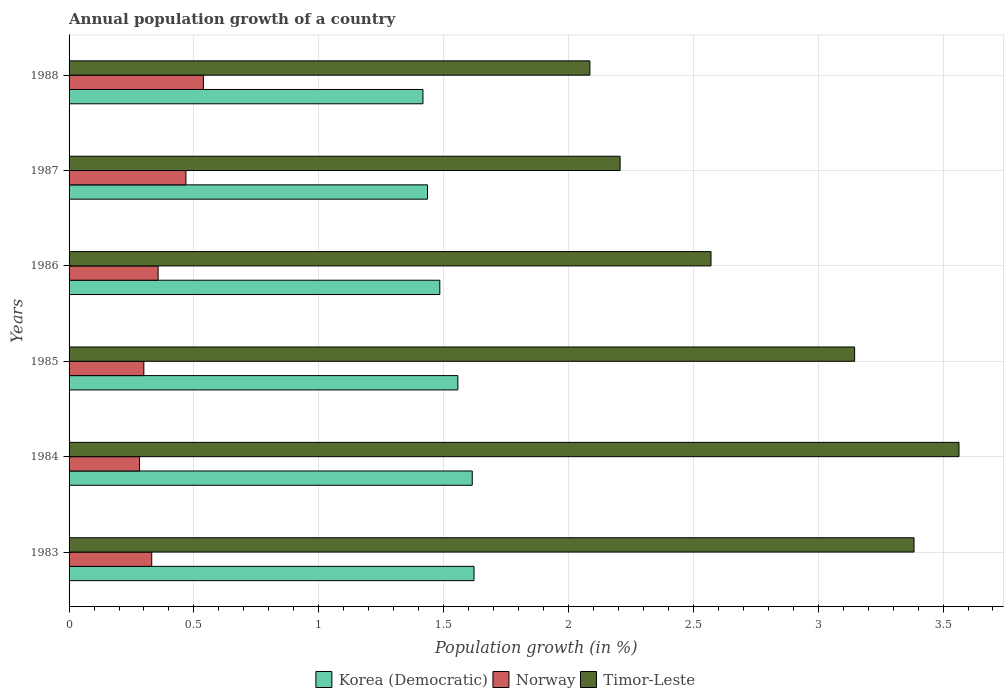How many different coloured bars are there?
Keep it short and to the point. 3. How many groups of bars are there?
Provide a succinct answer. 6. Are the number of bars per tick equal to the number of legend labels?
Provide a succinct answer. Yes. How many bars are there on the 2nd tick from the top?
Give a very brief answer. 3. What is the label of the 2nd group of bars from the top?
Your response must be concise. 1987. What is the annual population growth in Korea (Democratic) in 1987?
Offer a very short reply. 1.44. Across all years, what is the maximum annual population growth in Korea (Democratic)?
Your answer should be compact. 1.62. Across all years, what is the minimum annual population growth in Korea (Democratic)?
Your answer should be compact. 1.42. In which year was the annual population growth in Timor-Leste maximum?
Give a very brief answer. 1984. What is the total annual population growth in Norway in the graph?
Give a very brief answer. 2.28. What is the difference between the annual population growth in Korea (Democratic) in 1983 and that in 1986?
Ensure brevity in your answer.  0.14. What is the difference between the annual population growth in Norway in 1988 and the annual population growth in Timor-Leste in 1983?
Keep it short and to the point. -2.85. What is the average annual population growth in Korea (Democratic) per year?
Offer a terse response. 1.52. In the year 1987, what is the difference between the annual population growth in Timor-Leste and annual population growth in Korea (Democratic)?
Offer a terse response. 0.77. In how many years, is the annual population growth in Korea (Democratic) greater than 2.7 %?
Offer a very short reply. 0. What is the ratio of the annual population growth in Korea (Democratic) in 1986 to that in 1987?
Provide a succinct answer. 1.03. Is the annual population growth in Timor-Leste in 1984 less than that in 1988?
Your response must be concise. No. Is the difference between the annual population growth in Timor-Leste in 1985 and 1986 greater than the difference between the annual population growth in Korea (Democratic) in 1985 and 1986?
Offer a very short reply. Yes. What is the difference between the highest and the second highest annual population growth in Korea (Democratic)?
Your response must be concise. 0.01. What is the difference between the highest and the lowest annual population growth in Korea (Democratic)?
Provide a succinct answer. 0.2. In how many years, is the annual population growth in Timor-Leste greater than the average annual population growth in Timor-Leste taken over all years?
Give a very brief answer. 3. What does the 2nd bar from the bottom in 1987 represents?
Offer a terse response. Norway. Are all the bars in the graph horizontal?
Ensure brevity in your answer.  Yes. What is the difference between two consecutive major ticks on the X-axis?
Provide a short and direct response. 0.5. Does the graph contain any zero values?
Offer a very short reply. No. Does the graph contain grids?
Give a very brief answer. Yes. How many legend labels are there?
Keep it short and to the point. 3. What is the title of the graph?
Offer a terse response. Annual population growth of a country. What is the label or title of the X-axis?
Offer a terse response. Population growth (in %). What is the label or title of the Y-axis?
Your answer should be compact. Years. What is the Population growth (in %) in Korea (Democratic) in 1983?
Your response must be concise. 1.62. What is the Population growth (in %) in Norway in 1983?
Offer a terse response. 0.33. What is the Population growth (in %) of Timor-Leste in 1983?
Your answer should be very brief. 3.38. What is the Population growth (in %) of Korea (Democratic) in 1984?
Make the answer very short. 1.61. What is the Population growth (in %) in Norway in 1984?
Ensure brevity in your answer.  0.28. What is the Population growth (in %) in Timor-Leste in 1984?
Keep it short and to the point. 3.56. What is the Population growth (in %) in Korea (Democratic) in 1985?
Your answer should be compact. 1.56. What is the Population growth (in %) in Norway in 1985?
Your answer should be very brief. 0.3. What is the Population growth (in %) of Timor-Leste in 1985?
Provide a succinct answer. 3.15. What is the Population growth (in %) in Korea (Democratic) in 1986?
Your answer should be very brief. 1.48. What is the Population growth (in %) of Norway in 1986?
Provide a succinct answer. 0.36. What is the Population growth (in %) of Timor-Leste in 1986?
Provide a short and direct response. 2.57. What is the Population growth (in %) in Korea (Democratic) in 1987?
Give a very brief answer. 1.44. What is the Population growth (in %) of Norway in 1987?
Your answer should be compact. 0.47. What is the Population growth (in %) in Timor-Leste in 1987?
Give a very brief answer. 2.21. What is the Population growth (in %) in Korea (Democratic) in 1988?
Offer a very short reply. 1.42. What is the Population growth (in %) of Norway in 1988?
Give a very brief answer. 0.54. What is the Population growth (in %) of Timor-Leste in 1988?
Offer a terse response. 2.09. Across all years, what is the maximum Population growth (in %) of Korea (Democratic)?
Provide a succinct answer. 1.62. Across all years, what is the maximum Population growth (in %) in Norway?
Your answer should be compact. 0.54. Across all years, what is the maximum Population growth (in %) in Timor-Leste?
Make the answer very short. 3.56. Across all years, what is the minimum Population growth (in %) of Korea (Democratic)?
Your answer should be compact. 1.42. Across all years, what is the minimum Population growth (in %) in Norway?
Ensure brevity in your answer.  0.28. Across all years, what is the minimum Population growth (in %) in Timor-Leste?
Keep it short and to the point. 2.09. What is the total Population growth (in %) of Korea (Democratic) in the graph?
Make the answer very short. 9.13. What is the total Population growth (in %) of Norway in the graph?
Your answer should be very brief. 2.28. What is the total Population growth (in %) in Timor-Leste in the graph?
Keep it short and to the point. 16.96. What is the difference between the Population growth (in %) in Korea (Democratic) in 1983 and that in 1984?
Your response must be concise. 0.01. What is the difference between the Population growth (in %) of Norway in 1983 and that in 1984?
Offer a very short reply. 0.05. What is the difference between the Population growth (in %) in Timor-Leste in 1983 and that in 1984?
Ensure brevity in your answer.  -0.18. What is the difference between the Population growth (in %) of Korea (Democratic) in 1983 and that in 1985?
Your response must be concise. 0.06. What is the difference between the Population growth (in %) in Norway in 1983 and that in 1985?
Ensure brevity in your answer.  0.03. What is the difference between the Population growth (in %) in Timor-Leste in 1983 and that in 1985?
Give a very brief answer. 0.24. What is the difference between the Population growth (in %) of Korea (Democratic) in 1983 and that in 1986?
Provide a succinct answer. 0.14. What is the difference between the Population growth (in %) in Norway in 1983 and that in 1986?
Make the answer very short. -0.03. What is the difference between the Population growth (in %) of Timor-Leste in 1983 and that in 1986?
Your answer should be compact. 0.81. What is the difference between the Population growth (in %) in Korea (Democratic) in 1983 and that in 1987?
Give a very brief answer. 0.19. What is the difference between the Population growth (in %) of Norway in 1983 and that in 1987?
Make the answer very short. -0.14. What is the difference between the Population growth (in %) of Timor-Leste in 1983 and that in 1987?
Offer a very short reply. 1.18. What is the difference between the Population growth (in %) in Korea (Democratic) in 1983 and that in 1988?
Provide a succinct answer. 0.2. What is the difference between the Population growth (in %) in Norway in 1983 and that in 1988?
Give a very brief answer. -0.21. What is the difference between the Population growth (in %) of Timor-Leste in 1983 and that in 1988?
Offer a very short reply. 1.3. What is the difference between the Population growth (in %) of Korea (Democratic) in 1984 and that in 1985?
Provide a short and direct response. 0.06. What is the difference between the Population growth (in %) in Norway in 1984 and that in 1985?
Provide a short and direct response. -0.02. What is the difference between the Population growth (in %) in Timor-Leste in 1984 and that in 1985?
Offer a terse response. 0.42. What is the difference between the Population growth (in %) of Korea (Democratic) in 1984 and that in 1986?
Provide a succinct answer. 0.13. What is the difference between the Population growth (in %) of Norway in 1984 and that in 1986?
Make the answer very short. -0.07. What is the difference between the Population growth (in %) of Korea (Democratic) in 1984 and that in 1987?
Offer a terse response. 0.18. What is the difference between the Population growth (in %) of Norway in 1984 and that in 1987?
Your answer should be compact. -0.19. What is the difference between the Population growth (in %) of Timor-Leste in 1984 and that in 1987?
Give a very brief answer. 1.36. What is the difference between the Population growth (in %) in Korea (Democratic) in 1984 and that in 1988?
Offer a very short reply. 0.2. What is the difference between the Population growth (in %) of Norway in 1984 and that in 1988?
Your answer should be compact. -0.26. What is the difference between the Population growth (in %) of Timor-Leste in 1984 and that in 1988?
Give a very brief answer. 1.48. What is the difference between the Population growth (in %) in Korea (Democratic) in 1985 and that in 1986?
Ensure brevity in your answer.  0.07. What is the difference between the Population growth (in %) in Norway in 1985 and that in 1986?
Your answer should be compact. -0.06. What is the difference between the Population growth (in %) in Timor-Leste in 1985 and that in 1986?
Your answer should be very brief. 0.58. What is the difference between the Population growth (in %) in Korea (Democratic) in 1985 and that in 1987?
Offer a terse response. 0.12. What is the difference between the Population growth (in %) of Norway in 1985 and that in 1987?
Ensure brevity in your answer.  -0.17. What is the difference between the Population growth (in %) in Timor-Leste in 1985 and that in 1987?
Your response must be concise. 0.94. What is the difference between the Population growth (in %) of Korea (Democratic) in 1985 and that in 1988?
Your response must be concise. 0.14. What is the difference between the Population growth (in %) of Norway in 1985 and that in 1988?
Offer a terse response. -0.24. What is the difference between the Population growth (in %) of Timor-Leste in 1985 and that in 1988?
Provide a short and direct response. 1.06. What is the difference between the Population growth (in %) in Korea (Democratic) in 1986 and that in 1987?
Your answer should be very brief. 0.05. What is the difference between the Population growth (in %) of Norway in 1986 and that in 1987?
Provide a succinct answer. -0.11. What is the difference between the Population growth (in %) in Timor-Leste in 1986 and that in 1987?
Your answer should be compact. 0.36. What is the difference between the Population growth (in %) of Korea (Democratic) in 1986 and that in 1988?
Offer a terse response. 0.07. What is the difference between the Population growth (in %) of Norway in 1986 and that in 1988?
Provide a succinct answer. -0.18. What is the difference between the Population growth (in %) in Timor-Leste in 1986 and that in 1988?
Give a very brief answer. 0.48. What is the difference between the Population growth (in %) in Korea (Democratic) in 1987 and that in 1988?
Provide a short and direct response. 0.02. What is the difference between the Population growth (in %) in Norway in 1987 and that in 1988?
Provide a short and direct response. -0.07. What is the difference between the Population growth (in %) in Timor-Leste in 1987 and that in 1988?
Provide a succinct answer. 0.12. What is the difference between the Population growth (in %) in Korea (Democratic) in 1983 and the Population growth (in %) in Norway in 1984?
Your answer should be compact. 1.34. What is the difference between the Population growth (in %) in Korea (Democratic) in 1983 and the Population growth (in %) in Timor-Leste in 1984?
Provide a succinct answer. -1.94. What is the difference between the Population growth (in %) of Norway in 1983 and the Population growth (in %) of Timor-Leste in 1984?
Ensure brevity in your answer.  -3.23. What is the difference between the Population growth (in %) in Korea (Democratic) in 1983 and the Population growth (in %) in Norway in 1985?
Your answer should be very brief. 1.32. What is the difference between the Population growth (in %) in Korea (Democratic) in 1983 and the Population growth (in %) in Timor-Leste in 1985?
Keep it short and to the point. -1.52. What is the difference between the Population growth (in %) in Norway in 1983 and the Population growth (in %) in Timor-Leste in 1985?
Offer a very short reply. -2.81. What is the difference between the Population growth (in %) of Korea (Democratic) in 1983 and the Population growth (in %) of Norway in 1986?
Make the answer very short. 1.26. What is the difference between the Population growth (in %) of Korea (Democratic) in 1983 and the Population growth (in %) of Timor-Leste in 1986?
Offer a very short reply. -0.95. What is the difference between the Population growth (in %) of Norway in 1983 and the Population growth (in %) of Timor-Leste in 1986?
Offer a terse response. -2.24. What is the difference between the Population growth (in %) of Korea (Democratic) in 1983 and the Population growth (in %) of Norway in 1987?
Ensure brevity in your answer.  1.15. What is the difference between the Population growth (in %) in Korea (Democratic) in 1983 and the Population growth (in %) in Timor-Leste in 1987?
Offer a very short reply. -0.59. What is the difference between the Population growth (in %) of Norway in 1983 and the Population growth (in %) of Timor-Leste in 1987?
Make the answer very short. -1.88. What is the difference between the Population growth (in %) of Korea (Democratic) in 1983 and the Population growth (in %) of Norway in 1988?
Provide a succinct answer. 1.08. What is the difference between the Population growth (in %) in Korea (Democratic) in 1983 and the Population growth (in %) in Timor-Leste in 1988?
Keep it short and to the point. -0.46. What is the difference between the Population growth (in %) in Norway in 1983 and the Population growth (in %) in Timor-Leste in 1988?
Offer a very short reply. -1.75. What is the difference between the Population growth (in %) of Korea (Democratic) in 1984 and the Population growth (in %) of Norway in 1985?
Offer a terse response. 1.32. What is the difference between the Population growth (in %) of Korea (Democratic) in 1984 and the Population growth (in %) of Timor-Leste in 1985?
Your answer should be compact. -1.53. What is the difference between the Population growth (in %) in Norway in 1984 and the Population growth (in %) in Timor-Leste in 1985?
Your answer should be compact. -2.86. What is the difference between the Population growth (in %) of Korea (Democratic) in 1984 and the Population growth (in %) of Norway in 1986?
Your answer should be very brief. 1.26. What is the difference between the Population growth (in %) in Korea (Democratic) in 1984 and the Population growth (in %) in Timor-Leste in 1986?
Give a very brief answer. -0.96. What is the difference between the Population growth (in %) in Norway in 1984 and the Population growth (in %) in Timor-Leste in 1986?
Your response must be concise. -2.29. What is the difference between the Population growth (in %) in Korea (Democratic) in 1984 and the Population growth (in %) in Norway in 1987?
Ensure brevity in your answer.  1.15. What is the difference between the Population growth (in %) in Korea (Democratic) in 1984 and the Population growth (in %) in Timor-Leste in 1987?
Ensure brevity in your answer.  -0.59. What is the difference between the Population growth (in %) in Norway in 1984 and the Population growth (in %) in Timor-Leste in 1987?
Provide a succinct answer. -1.92. What is the difference between the Population growth (in %) of Korea (Democratic) in 1984 and the Population growth (in %) of Norway in 1988?
Make the answer very short. 1.08. What is the difference between the Population growth (in %) of Korea (Democratic) in 1984 and the Population growth (in %) of Timor-Leste in 1988?
Your response must be concise. -0.47. What is the difference between the Population growth (in %) of Norway in 1984 and the Population growth (in %) of Timor-Leste in 1988?
Your answer should be very brief. -1.8. What is the difference between the Population growth (in %) in Korea (Democratic) in 1985 and the Population growth (in %) in Norway in 1986?
Your answer should be compact. 1.2. What is the difference between the Population growth (in %) in Korea (Democratic) in 1985 and the Population growth (in %) in Timor-Leste in 1986?
Your answer should be compact. -1.01. What is the difference between the Population growth (in %) of Norway in 1985 and the Population growth (in %) of Timor-Leste in 1986?
Offer a very short reply. -2.27. What is the difference between the Population growth (in %) in Korea (Democratic) in 1985 and the Population growth (in %) in Norway in 1987?
Provide a short and direct response. 1.09. What is the difference between the Population growth (in %) of Korea (Democratic) in 1985 and the Population growth (in %) of Timor-Leste in 1987?
Give a very brief answer. -0.65. What is the difference between the Population growth (in %) in Norway in 1985 and the Population growth (in %) in Timor-Leste in 1987?
Ensure brevity in your answer.  -1.91. What is the difference between the Population growth (in %) in Korea (Democratic) in 1985 and the Population growth (in %) in Timor-Leste in 1988?
Make the answer very short. -0.53. What is the difference between the Population growth (in %) of Norway in 1985 and the Population growth (in %) of Timor-Leste in 1988?
Your answer should be very brief. -1.79. What is the difference between the Population growth (in %) of Korea (Democratic) in 1986 and the Population growth (in %) of Norway in 1987?
Provide a succinct answer. 1.02. What is the difference between the Population growth (in %) of Korea (Democratic) in 1986 and the Population growth (in %) of Timor-Leste in 1987?
Offer a very short reply. -0.72. What is the difference between the Population growth (in %) in Norway in 1986 and the Population growth (in %) in Timor-Leste in 1987?
Make the answer very short. -1.85. What is the difference between the Population growth (in %) in Korea (Democratic) in 1986 and the Population growth (in %) in Norway in 1988?
Keep it short and to the point. 0.95. What is the difference between the Population growth (in %) in Korea (Democratic) in 1986 and the Population growth (in %) in Timor-Leste in 1988?
Ensure brevity in your answer.  -0.6. What is the difference between the Population growth (in %) of Norway in 1986 and the Population growth (in %) of Timor-Leste in 1988?
Your response must be concise. -1.73. What is the difference between the Population growth (in %) of Korea (Democratic) in 1987 and the Population growth (in %) of Norway in 1988?
Offer a terse response. 0.9. What is the difference between the Population growth (in %) of Korea (Democratic) in 1987 and the Population growth (in %) of Timor-Leste in 1988?
Ensure brevity in your answer.  -0.65. What is the difference between the Population growth (in %) in Norway in 1987 and the Population growth (in %) in Timor-Leste in 1988?
Provide a succinct answer. -1.62. What is the average Population growth (in %) of Korea (Democratic) per year?
Keep it short and to the point. 1.52. What is the average Population growth (in %) in Norway per year?
Provide a succinct answer. 0.38. What is the average Population growth (in %) in Timor-Leste per year?
Give a very brief answer. 2.83. In the year 1983, what is the difference between the Population growth (in %) of Korea (Democratic) and Population growth (in %) of Norway?
Your answer should be very brief. 1.29. In the year 1983, what is the difference between the Population growth (in %) in Korea (Democratic) and Population growth (in %) in Timor-Leste?
Make the answer very short. -1.76. In the year 1983, what is the difference between the Population growth (in %) of Norway and Population growth (in %) of Timor-Leste?
Make the answer very short. -3.05. In the year 1984, what is the difference between the Population growth (in %) in Korea (Democratic) and Population growth (in %) in Norway?
Offer a terse response. 1.33. In the year 1984, what is the difference between the Population growth (in %) of Korea (Democratic) and Population growth (in %) of Timor-Leste?
Provide a succinct answer. -1.95. In the year 1984, what is the difference between the Population growth (in %) of Norway and Population growth (in %) of Timor-Leste?
Offer a terse response. -3.28. In the year 1985, what is the difference between the Population growth (in %) of Korea (Democratic) and Population growth (in %) of Norway?
Your answer should be very brief. 1.26. In the year 1985, what is the difference between the Population growth (in %) of Korea (Democratic) and Population growth (in %) of Timor-Leste?
Provide a succinct answer. -1.59. In the year 1985, what is the difference between the Population growth (in %) in Norway and Population growth (in %) in Timor-Leste?
Offer a very short reply. -2.85. In the year 1986, what is the difference between the Population growth (in %) in Korea (Democratic) and Population growth (in %) in Norway?
Provide a short and direct response. 1.13. In the year 1986, what is the difference between the Population growth (in %) of Korea (Democratic) and Population growth (in %) of Timor-Leste?
Your response must be concise. -1.09. In the year 1986, what is the difference between the Population growth (in %) in Norway and Population growth (in %) in Timor-Leste?
Provide a succinct answer. -2.21. In the year 1987, what is the difference between the Population growth (in %) in Korea (Democratic) and Population growth (in %) in Norway?
Make the answer very short. 0.97. In the year 1987, what is the difference between the Population growth (in %) in Korea (Democratic) and Population growth (in %) in Timor-Leste?
Offer a very short reply. -0.77. In the year 1987, what is the difference between the Population growth (in %) of Norway and Population growth (in %) of Timor-Leste?
Ensure brevity in your answer.  -1.74. In the year 1988, what is the difference between the Population growth (in %) of Korea (Democratic) and Population growth (in %) of Norway?
Your answer should be compact. 0.88. In the year 1988, what is the difference between the Population growth (in %) of Korea (Democratic) and Population growth (in %) of Timor-Leste?
Offer a terse response. -0.67. In the year 1988, what is the difference between the Population growth (in %) of Norway and Population growth (in %) of Timor-Leste?
Keep it short and to the point. -1.55. What is the ratio of the Population growth (in %) of Norway in 1983 to that in 1984?
Provide a succinct answer. 1.17. What is the ratio of the Population growth (in %) in Timor-Leste in 1983 to that in 1984?
Keep it short and to the point. 0.95. What is the ratio of the Population growth (in %) of Korea (Democratic) in 1983 to that in 1985?
Ensure brevity in your answer.  1.04. What is the ratio of the Population growth (in %) of Norway in 1983 to that in 1985?
Keep it short and to the point. 1.11. What is the ratio of the Population growth (in %) in Timor-Leste in 1983 to that in 1985?
Ensure brevity in your answer.  1.08. What is the ratio of the Population growth (in %) of Korea (Democratic) in 1983 to that in 1986?
Your answer should be compact. 1.09. What is the ratio of the Population growth (in %) of Norway in 1983 to that in 1986?
Your answer should be compact. 0.93. What is the ratio of the Population growth (in %) of Timor-Leste in 1983 to that in 1986?
Offer a very short reply. 1.32. What is the ratio of the Population growth (in %) of Korea (Democratic) in 1983 to that in 1987?
Provide a short and direct response. 1.13. What is the ratio of the Population growth (in %) in Norway in 1983 to that in 1987?
Ensure brevity in your answer.  0.71. What is the ratio of the Population growth (in %) in Timor-Leste in 1983 to that in 1987?
Offer a very short reply. 1.53. What is the ratio of the Population growth (in %) in Korea (Democratic) in 1983 to that in 1988?
Your answer should be compact. 1.14. What is the ratio of the Population growth (in %) in Norway in 1983 to that in 1988?
Offer a terse response. 0.62. What is the ratio of the Population growth (in %) of Timor-Leste in 1983 to that in 1988?
Your response must be concise. 1.62. What is the ratio of the Population growth (in %) in Korea (Democratic) in 1984 to that in 1985?
Your answer should be compact. 1.04. What is the ratio of the Population growth (in %) of Norway in 1984 to that in 1985?
Offer a terse response. 0.94. What is the ratio of the Population growth (in %) of Timor-Leste in 1984 to that in 1985?
Your response must be concise. 1.13. What is the ratio of the Population growth (in %) in Korea (Democratic) in 1984 to that in 1986?
Keep it short and to the point. 1.09. What is the ratio of the Population growth (in %) in Norway in 1984 to that in 1986?
Your answer should be compact. 0.79. What is the ratio of the Population growth (in %) in Timor-Leste in 1984 to that in 1986?
Make the answer very short. 1.39. What is the ratio of the Population growth (in %) of Korea (Democratic) in 1984 to that in 1987?
Your response must be concise. 1.12. What is the ratio of the Population growth (in %) of Norway in 1984 to that in 1987?
Make the answer very short. 0.6. What is the ratio of the Population growth (in %) of Timor-Leste in 1984 to that in 1987?
Provide a succinct answer. 1.61. What is the ratio of the Population growth (in %) in Korea (Democratic) in 1984 to that in 1988?
Offer a very short reply. 1.14. What is the ratio of the Population growth (in %) of Norway in 1984 to that in 1988?
Provide a succinct answer. 0.52. What is the ratio of the Population growth (in %) in Timor-Leste in 1984 to that in 1988?
Ensure brevity in your answer.  1.71. What is the ratio of the Population growth (in %) of Korea (Democratic) in 1985 to that in 1986?
Provide a succinct answer. 1.05. What is the ratio of the Population growth (in %) of Norway in 1985 to that in 1986?
Ensure brevity in your answer.  0.84. What is the ratio of the Population growth (in %) of Timor-Leste in 1985 to that in 1986?
Make the answer very short. 1.22. What is the ratio of the Population growth (in %) of Korea (Democratic) in 1985 to that in 1987?
Keep it short and to the point. 1.08. What is the ratio of the Population growth (in %) of Norway in 1985 to that in 1987?
Ensure brevity in your answer.  0.64. What is the ratio of the Population growth (in %) of Timor-Leste in 1985 to that in 1987?
Your response must be concise. 1.43. What is the ratio of the Population growth (in %) in Korea (Democratic) in 1985 to that in 1988?
Give a very brief answer. 1.1. What is the ratio of the Population growth (in %) in Norway in 1985 to that in 1988?
Your response must be concise. 0.56. What is the ratio of the Population growth (in %) in Timor-Leste in 1985 to that in 1988?
Ensure brevity in your answer.  1.51. What is the ratio of the Population growth (in %) of Korea (Democratic) in 1986 to that in 1987?
Your response must be concise. 1.03. What is the ratio of the Population growth (in %) in Norway in 1986 to that in 1987?
Offer a very short reply. 0.76. What is the ratio of the Population growth (in %) of Timor-Leste in 1986 to that in 1987?
Provide a short and direct response. 1.17. What is the ratio of the Population growth (in %) of Korea (Democratic) in 1986 to that in 1988?
Provide a short and direct response. 1.05. What is the ratio of the Population growth (in %) in Norway in 1986 to that in 1988?
Your response must be concise. 0.66. What is the ratio of the Population growth (in %) of Timor-Leste in 1986 to that in 1988?
Your answer should be very brief. 1.23. What is the ratio of the Population growth (in %) of Korea (Democratic) in 1987 to that in 1988?
Offer a very short reply. 1.01. What is the ratio of the Population growth (in %) of Norway in 1987 to that in 1988?
Offer a very short reply. 0.87. What is the ratio of the Population growth (in %) in Timor-Leste in 1987 to that in 1988?
Ensure brevity in your answer.  1.06. What is the difference between the highest and the second highest Population growth (in %) in Korea (Democratic)?
Offer a terse response. 0.01. What is the difference between the highest and the second highest Population growth (in %) of Norway?
Keep it short and to the point. 0.07. What is the difference between the highest and the second highest Population growth (in %) of Timor-Leste?
Your answer should be very brief. 0.18. What is the difference between the highest and the lowest Population growth (in %) of Korea (Democratic)?
Provide a short and direct response. 0.2. What is the difference between the highest and the lowest Population growth (in %) of Norway?
Keep it short and to the point. 0.26. What is the difference between the highest and the lowest Population growth (in %) in Timor-Leste?
Provide a succinct answer. 1.48. 